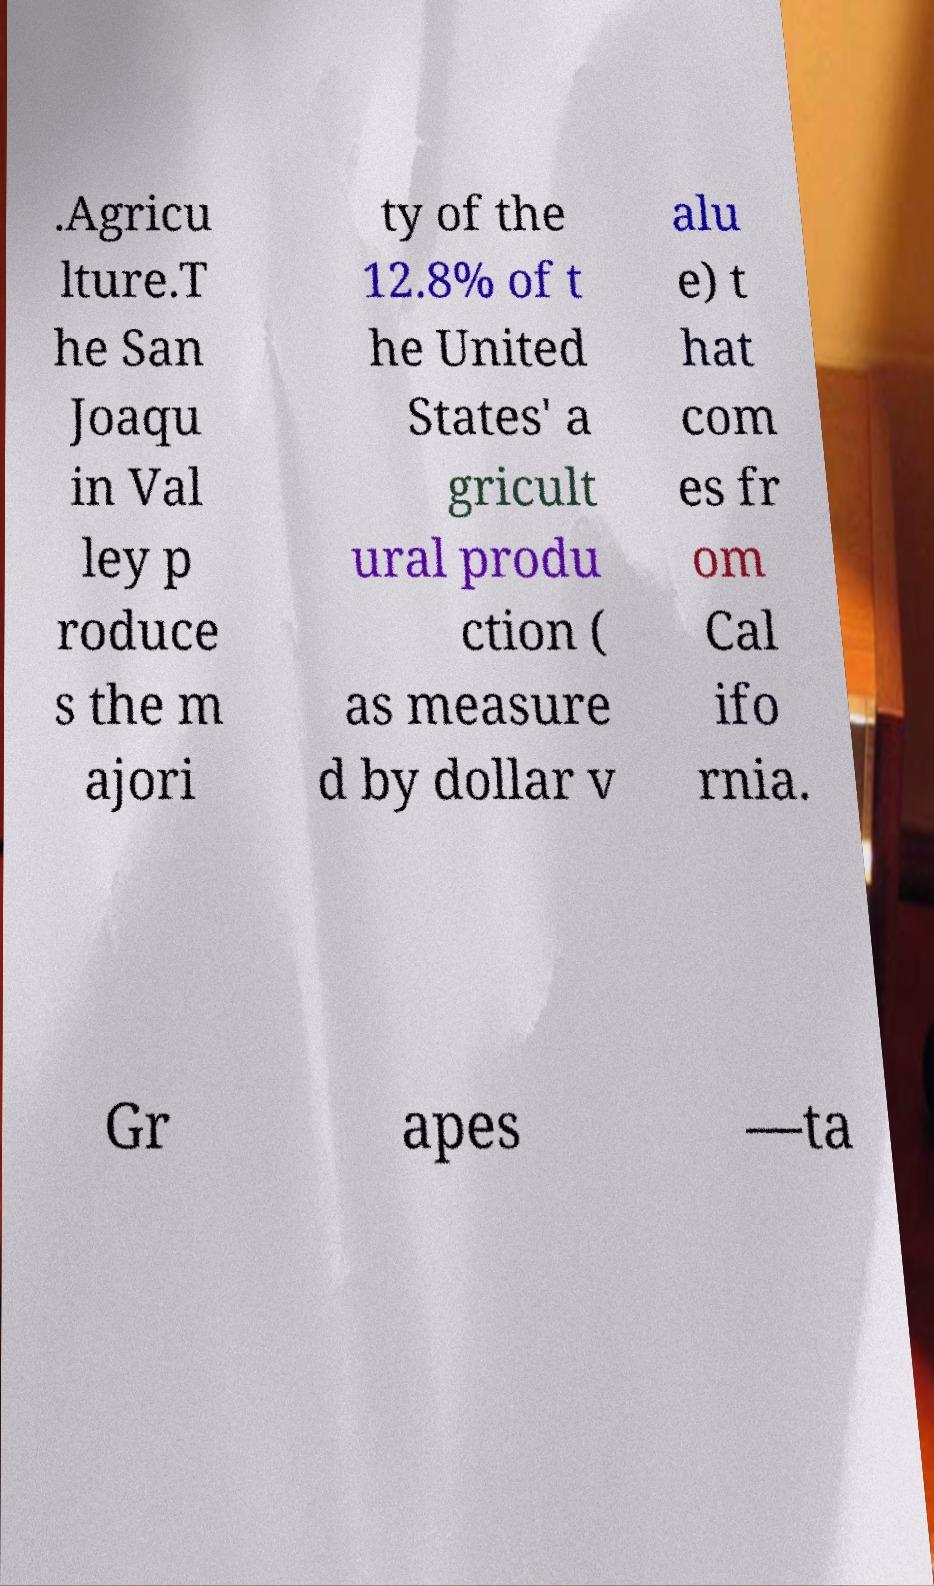There's text embedded in this image that I need extracted. Can you transcribe it verbatim? .Agricu lture.T he San Joaqu in Val ley p roduce s the m ajori ty of the 12.8% of t he United States' a gricult ural produ ction ( as measure d by dollar v alu e) t hat com es fr om Cal ifo rnia. Gr apes —ta 